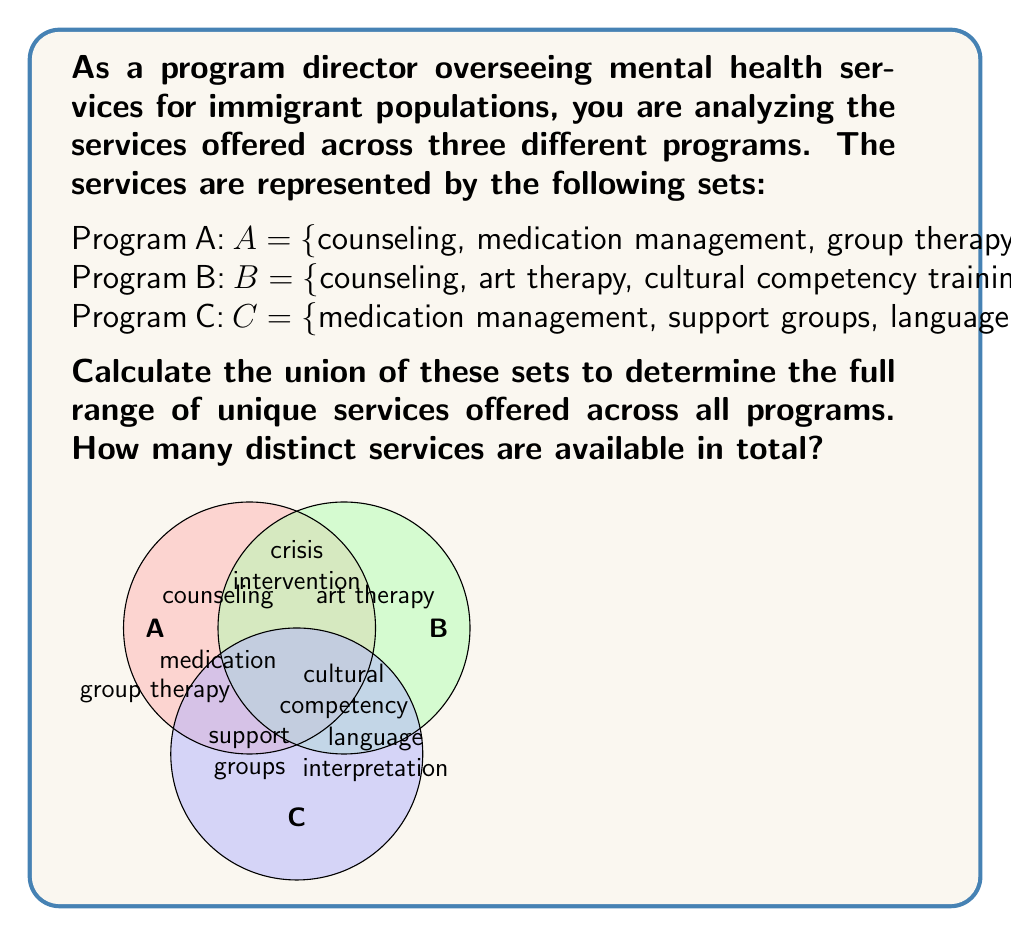Help me with this question. To solve this problem, we need to find the union of sets A, B, and C. The union of sets includes all unique elements from all sets, without duplicates. Let's approach this step-by-step:

1) First, let's list out all the services from all programs:
   $A \cup B \cup C = \{$counseling, medication management, group therapy, crisis intervention, art therapy, cultural competency training, support groups, language interpretation$\}$

2) Now, let's count the unique services:
   - counseling
   - medication management
   - group therapy
   - crisis intervention
   - art therapy
   - cultural competency training
   - support groups
   - language interpretation

3) We can see that there are no duplicates in this list.

4) To formally express this in set notation:
   $$|A \cup B \cup C| = |\{$counseling, medication management, group therapy, crisis intervention, art therapy, cultural competency training, support groups, language interpretation$\}|$$

5) Count the elements in this set:
   $$|A \cup B \cup C| = 8$$

Therefore, there are 8 distinct services available across all programs.
Answer: 8 